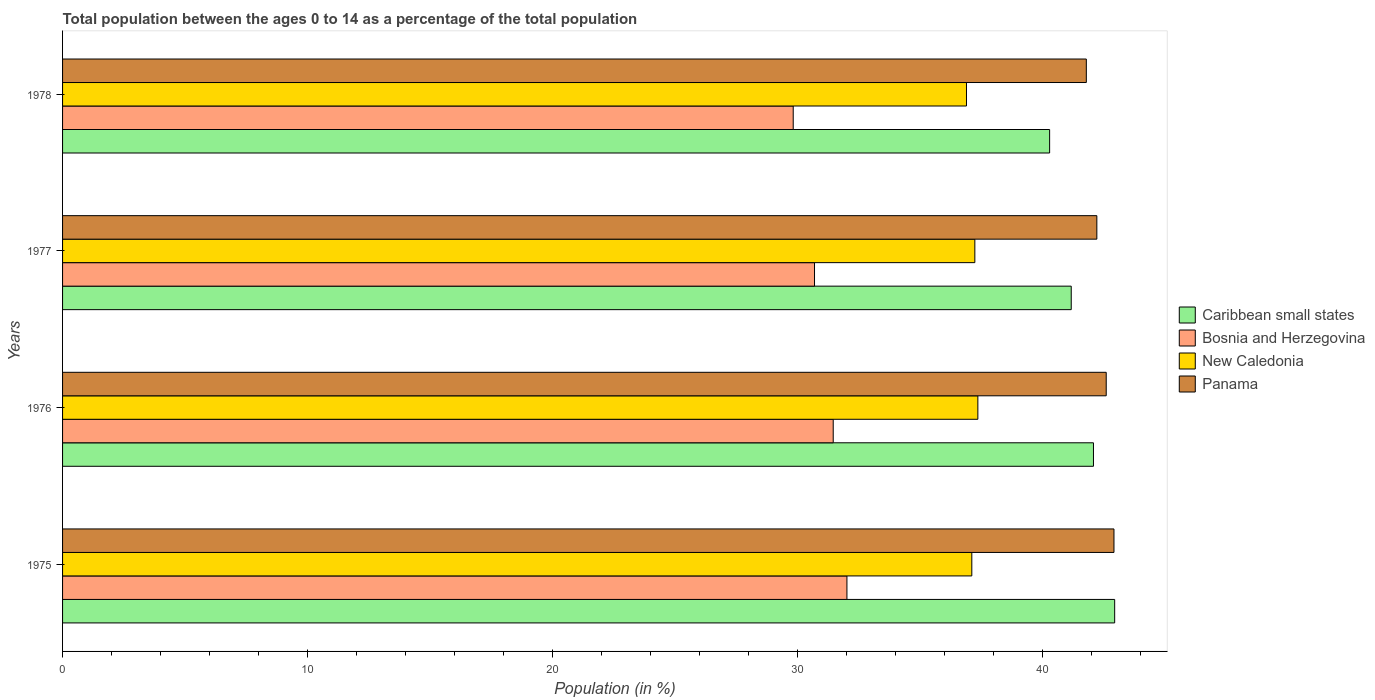How many different coloured bars are there?
Your response must be concise. 4. How many groups of bars are there?
Make the answer very short. 4. Are the number of bars per tick equal to the number of legend labels?
Provide a short and direct response. Yes. Are the number of bars on each tick of the Y-axis equal?
Make the answer very short. Yes. How many bars are there on the 3rd tick from the top?
Provide a short and direct response. 4. How many bars are there on the 4th tick from the bottom?
Your response must be concise. 4. What is the percentage of the population ages 0 to 14 in Panama in 1978?
Make the answer very short. 41.8. Across all years, what is the maximum percentage of the population ages 0 to 14 in Caribbean small states?
Your answer should be compact. 42.95. Across all years, what is the minimum percentage of the population ages 0 to 14 in Panama?
Provide a succinct answer. 41.8. In which year was the percentage of the population ages 0 to 14 in New Caledonia maximum?
Ensure brevity in your answer.  1976. In which year was the percentage of the population ages 0 to 14 in Panama minimum?
Your response must be concise. 1978. What is the total percentage of the population ages 0 to 14 in Caribbean small states in the graph?
Ensure brevity in your answer.  166.52. What is the difference between the percentage of the population ages 0 to 14 in Panama in 1975 and that in 1977?
Offer a terse response. 0.7. What is the difference between the percentage of the population ages 0 to 14 in Bosnia and Herzegovina in 1975 and the percentage of the population ages 0 to 14 in Panama in 1976?
Make the answer very short. -10.59. What is the average percentage of the population ages 0 to 14 in Bosnia and Herzegovina per year?
Keep it short and to the point. 31. In the year 1977, what is the difference between the percentage of the population ages 0 to 14 in New Caledonia and percentage of the population ages 0 to 14 in Bosnia and Herzegovina?
Make the answer very short. 6.55. In how many years, is the percentage of the population ages 0 to 14 in Bosnia and Herzegovina greater than 40 ?
Your answer should be very brief. 0. What is the ratio of the percentage of the population ages 0 to 14 in Panama in 1975 to that in 1977?
Your answer should be compact. 1.02. What is the difference between the highest and the second highest percentage of the population ages 0 to 14 in New Caledonia?
Offer a very short reply. 0.12. What is the difference between the highest and the lowest percentage of the population ages 0 to 14 in Panama?
Ensure brevity in your answer.  1.13. In how many years, is the percentage of the population ages 0 to 14 in Panama greater than the average percentage of the population ages 0 to 14 in Panama taken over all years?
Your answer should be very brief. 2. Is it the case that in every year, the sum of the percentage of the population ages 0 to 14 in Caribbean small states and percentage of the population ages 0 to 14 in Panama is greater than the sum of percentage of the population ages 0 to 14 in Bosnia and Herzegovina and percentage of the population ages 0 to 14 in New Caledonia?
Offer a terse response. Yes. What does the 1st bar from the top in 1978 represents?
Offer a very short reply. Panama. What does the 1st bar from the bottom in 1978 represents?
Offer a very short reply. Caribbean small states. Is it the case that in every year, the sum of the percentage of the population ages 0 to 14 in Caribbean small states and percentage of the population ages 0 to 14 in Bosnia and Herzegovina is greater than the percentage of the population ages 0 to 14 in Panama?
Provide a succinct answer. Yes. What is the difference between two consecutive major ticks on the X-axis?
Provide a succinct answer. 10. Are the values on the major ticks of X-axis written in scientific E-notation?
Offer a terse response. No. Does the graph contain any zero values?
Provide a succinct answer. No. How many legend labels are there?
Make the answer very short. 4. How are the legend labels stacked?
Provide a short and direct response. Vertical. What is the title of the graph?
Provide a short and direct response. Total population between the ages 0 to 14 as a percentage of the total population. Does "Slovenia" appear as one of the legend labels in the graph?
Offer a terse response. No. What is the label or title of the X-axis?
Offer a terse response. Population (in %). What is the label or title of the Y-axis?
Provide a succinct answer. Years. What is the Population (in %) of Caribbean small states in 1975?
Give a very brief answer. 42.95. What is the Population (in %) in Bosnia and Herzegovina in 1975?
Provide a succinct answer. 32.02. What is the Population (in %) in New Caledonia in 1975?
Your answer should be very brief. 37.12. What is the Population (in %) in Panama in 1975?
Give a very brief answer. 42.93. What is the Population (in %) of Caribbean small states in 1976?
Provide a succinct answer. 42.09. What is the Population (in %) of Bosnia and Herzegovina in 1976?
Your answer should be very brief. 31.46. What is the Population (in %) in New Caledonia in 1976?
Ensure brevity in your answer.  37.37. What is the Population (in %) in Panama in 1976?
Your answer should be compact. 42.61. What is the Population (in %) of Caribbean small states in 1977?
Make the answer very short. 41.18. What is the Population (in %) of Bosnia and Herzegovina in 1977?
Ensure brevity in your answer.  30.7. What is the Population (in %) in New Caledonia in 1977?
Your response must be concise. 37.25. What is the Population (in %) in Panama in 1977?
Your answer should be compact. 42.23. What is the Population (in %) of Caribbean small states in 1978?
Provide a short and direct response. 40.3. What is the Population (in %) in Bosnia and Herzegovina in 1978?
Your response must be concise. 29.83. What is the Population (in %) in New Caledonia in 1978?
Provide a succinct answer. 36.9. What is the Population (in %) of Panama in 1978?
Make the answer very short. 41.8. Across all years, what is the maximum Population (in %) of Caribbean small states?
Ensure brevity in your answer.  42.95. Across all years, what is the maximum Population (in %) of Bosnia and Herzegovina?
Give a very brief answer. 32.02. Across all years, what is the maximum Population (in %) of New Caledonia?
Your answer should be compact. 37.37. Across all years, what is the maximum Population (in %) of Panama?
Offer a very short reply. 42.93. Across all years, what is the minimum Population (in %) in Caribbean small states?
Offer a terse response. 40.3. Across all years, what is the minimum Population (in %) in Bosnia and Herzegovina?
Your response must be concise. 29.83. Across all years, what is the minimum Population (in %) in New Caledonia?
Keep it short and to the point. 36.9. Across all years, what is the minimum Population (in %) of Panama?
Provide a succinct answer. 41.8. What is the total Population (in %) in Caribbean small states in the graph?
Your answer should be very brief. 166.52. What is the total Population (in %) in Bosnia and Herzegovina in the graph?
Ensure brevity in your answer.  124.02. What is the total Population (in %) in New Caledonia in the graph?
Keep it short and to the point. 148.64. What is the total Population (in %) in Panama in the graph?
Provide a succinct answer. 169.56. What is the difference between the Population (in %) in Caribbean small states in 1975 and that in 1976?
Ensure brevity in your answer.  0.87. What is the difference between the Population (in %) of Bosnia and Herzegovina in 1975 and that in 1976?
Make the answer very short. 0.56. What is the difference between the Population (in %) of New Caledonia in 1975 and that in 1976?
Keep it short and to the point. -0.25. What is the difference between the Population (in %) of Panama in 1975 and that in 1976?
Your answer should be very brief. 0.32. What is the difference between the Population (in %) of Caribbean small states in 1975 and that in 1977?
Offer a terse response. 1.77. What is the difference between the Population (in %) of Bosnia and Herzegovina in 1975 and that in 1977?
Offer a terse response. 1.32. What is the difference between the Population (in %) in New Caledonia in 1975 and that in 1977?
Offer a very short reply. -0.12. What is the difference between the Population (in %) of Panama in 1975 and that in 1977?
Make the answer very short. 0.7. What is the difference between the Population (in %) of Caribbean small states in 1975 and that in 1978?
Make the answer very short. 2.66. What is the difference between the Population (in %) in Bosnia and Herzegovina in 1975 and that in 1978?
Keep it short and to the point. 2.19. What is the difference between the Population (in %) in New Caledonia in 1975 and that in 1978?
Keep it short and to the point. 0.22. What is the difference between the Population (in %) in Panama in 1975 and that in 1978?
Make the answer very short. 1.13. What is the difference between the Population (in %) in Caribbean small states in 1976 and that in 1977?
Provide a short and direct response. 0.91. What is the difference between the Population (in %) of Bosnia and Herzegovina in 1976 and that in 1977?
Offer a very short reply. 0.76. What is the difference between the Population (in %) of New Caledonia in 1976 and that in 1977?
Make the answer very short. 0.12. What is the difference between the Population (in %) of Panama in 1976 and that in 1977?
Provide a short and direct response. 0.38. What is the difference between the Population (in %) in Caribbean small states in 1976 and that in 1978?
Your response must be concise. 1.79. What is the difference between the Population (in %) in Bosnia and Herzegovina in 1976 and that in 1978?
Ensure brevity in your answer.  1.63. What is the difference between the Population (in %) in New Caledonia in 1976 and that in 1978?
Ensure brevity in your answer.  0.46. What is the difference between the Population (in %) in Panama in 1976 and that in 1978?
Provide a succinct answer. 0.81. What is the difference between the Population (in %) of Caribbean small states in 1977 and that in 1978?
Provide a short and direct response. 0.88. What is the difference between the Population (in %) in Bosnia and Herzegovina in 1977 and that in 1978?
Offer a very short reply. 0.87. What is the difference between the Population (in %) in New Caledonia in 1977 and that in 1978?
Make the answer very short. 0.34. What is the difference between the Population (in %) in Panama in 1977 and that in 1978?
Offer a very short reply. 0.43. What is the difference between the Population (in %) in Caribbean small states in 1975 and the Population (in %) in Bosnia and Herzegovina in 1976?
Your response must be concise. 11.49. What is the difference between the Population (in %) of Caribbean small states in 1975 and the Population (in %) of New Caledonia in 1976?
Offer a very short reply. 5.59. What is the difference between the Population (in %) in Caribbean small states in 1975 and the Population (in %) in Panama in 1976?
Provide a succinct answer. 0.34. What is the difference between the Population (in %) in Bosnia and Herzegovina in 1975 and the Population (in %) in New Caledonia in 1976?
Give a very brief answer. -5.34. What is the difference between the Population (in %) of Bosnia and Herzegovina in 1975 and the Population (in %) of Panama in 1976?
Your response must be concise. -10.59. What is the difference between the Population (in %) of New Caledonia in 1975 and the Population (in %) of Panama in 1976?
Your answer should be compact. -5.49. What is the difference between the Population (in %) of Caribbean small states in 1975 and the Population (in %) of Bosnia and Herzegovina in 1977?
Your answer should be compact. 12.25. What is the difference between the Population (in %) of Caribbean small states in 1975 and the Population (in %) of New Caledonia in 1977?
Offer a very short reply. 5.71. What is the difference between the Population (in %) in Caribbean small states in 1975 and the Population (in %) in Panama in 1977?
Offer a terse response. 0.73. What is the difference between the Population (in %) of Bosnia and Herzegovina in 1975 and the Population (in %) of New Caledonia in 1977?
Offer a very short reply. -5.22. What is the difference between the Population (in %) in Bosnia and Herzegovina in 1975 and the Population (in %) in Panama in 1977?
Give a very brief answer. -10.2. What is the difference between the Population (in %) of New Caledonia in 1975 and the Population (in %) of Panama in 1977?
Provide a succinct answer. -5.1. What is the difference between the Population (in %) of Caribbean small states in 1975 and the Population (in %) of Bosnia and Herzegovina in 1978?
Provide a succinct answer. 13.12. What is the difference between the Population (in %) of Caribbean small states in 1975 and the Population (in %) of New Caledonia in 1978?
Your answer should be compact. 6.05. What is the difference between the Population (in %) of Caribbean small states in 1975 and the Population (in %) of Panama in 1978?
Your answer should be very brief. 1.16. What is the difference between the Population (in %) of Bosnia and Herzegovina in 1975 and the Population (in %) of New Caledonia in 1978?
Provide a short and direct response. -4.88. What is the difference between the Population (in %) of Bosnia and Herzegovina in 1975 and the Population (in %) of Panama in 1978?
Your answer should be very brief. -9.77. What is the difference between the Population (in %) of New Caledonia in 1975 and the Population (in %) of Panama in 1978?
Your answer should be very brief. -4.68. What is the difference between the Population (in %) of Caribbean small states in 1976 and the Population (in %) of Bosnia and Herzegovina in 1977?
Keep it short and to the point. 11.39. What is the difference between the Population (in %) of Caribbean small states in 1976 and the Population (in %) of New Caledonia in 1977?
Provide a short and direct response. 4.84. What is the difference between the Population (in %) in Caribbean small states in 1976 and the Population (in %) in Panama in 1977?
Provide a succinct answer. -0.14. What is the difference between the Population (in %) of Bosnia and Herzegovina in 1976 and the Population (in %) of New Caledonia in 1977?
Keep it short and to the point. -5.78. What is the difference between the Population (in %) of Bosnia and Herzegovina in 1976 and the Population (in %) of Panama in 1977?
Provide a succinct answer. -10.76. What is the difference between the Population (in %) of New Caledonia in 1976 and the Population (in %) of Panama in 1977?
Make the answer very short. -4.86. What is the difference between the Population (in %) of Caribbean small states in 1976 and the Population (in %) of Bosnia and Herzegovina in 1978?
Your answer should be very brief. 12.26. What is the difference between the Population (in %) of Caribbean small states in 1976 and the Population (in %) of New Caledonia in 1978?
Your answer should be compact. 5.18. What is the difference between the Population (in %) of Caribbean small states in 1976 and the Population (in %) of Panama in 1978?
Ensure brevity in your answer.  0.29. What is the difference between the Population (in %) in Bosnia and Herzegovina in 1976 and the Population (in %) in New Caledonia in 1978?
Make the answer very short. -5.44. What is the difference between the Population (in %) in Bosnia and Herzegovina in 1976 and the Population (in %) in Panama in 1978?
Make the answer very short. -10.33. What is the difference between the Population (in %) of New Caledonia in 1976 and the Population (in %) of Panama in 1978?
Give a very brief answer. -4.43. What is the difference between the Population (in %) of Caribbean small states in 1977 and the Population (in %) of Bosnia and Herzegovina in 1978?
Make the answer very short. 11.35. What is the difference between the Population (in %) in Caribbean small states in 1977 and the Population (in %) in New Caledonia in 1978?
Make the answer very short. 4.28. What is the difference between the Population (in %) of Caribbean small states in 1977 and the Population (in %) of Panama in 1978?
Offer a terse response. -0.62. What is the difference between the Population (in %) of Bosnia and Herzegovina in 1977 and the Population (in %) of New Caledonia in 1978?
Offer a terse response. -6.2. What is the difference between the Population (in %) of Bosnia and Herzegovina in 1977 and the Population (in %) of Panama in 1978?
Your answer should be compact. -11.1. What is the difference between the Population (in %) in New Caledonia in 1977 and the Population (in %) in Panama in 1978?
Offer a terse response. -4.55. What is the average Population (in %) of Caribbean small states per year?
Provide a succinct answer. 41.63. What is the average Population (in %) in Bosnia and Herzegovina per year?
Offer a very short reply. 31. What is the average Population (in %) in New Caledonia per year?
Offer a very short reply. 37.16. What is the average Population (in %) of Panama per year?
Offer a very short reply. 42.39. In the year 1975, what is the difference between the Population (in %) of Caribbean small states and Population (in %) of Bosnia and Herzegovina?
Keep it short and to the point. 10.93. In the year 1975, what is the difference between the Population (in %) of Caribbean small states and Population (in %) of New Caledonia?
Your answer should be compact. 5.83. In the year 1975, what is the difference between the Population (in %) of Caribbean small states and Population (in %) of Panama?
Give a very brief answer. 0.03. In the year 1975, what is the difference between the Population (in %) of Bosnia and Herzegovina and Population (in %) of New Caledonia?
Keep it short and to the point. -5.1. In the year 1975, what is the difference between the Population (in %) of Bosnia and Herzegovina and Population (in %) of Panama?
Your answer should be compact. -10.9. In the year 1975, what is the difference between the Population (in %) of New Caledonia and Population (in %) of Panama?
Ensure brevity in your answer.  -5.8. In the year 1976, what is the difference between the Population (in %) in Caribbean small states and Population (in %) in Bosnia and Herzegovina?
Give a very brief answer. 10.62. In the year 1976, what is the difference between the Population (in %) in Caribbean small states and Population (in %) in New Caledonia?
Provide a short and direct response. 4.72. In the year 1976, what is the difference between the Population (in %) in Caribbean small states and Population (in %) in Panama?
Provide a short and direct response. -0.52. In the year 1976, what is the difference between the Population (in %) in Bosnia and Herzegovina and Population (in %) in New Caledonia?
Provide a succinct answer. -5.91. In the year 1976, what is the difference between the Population (in %) in Bosnia and Herzegovina and Population (in %) in Panama?
Your response must be concise. -11.15. In the year 1976, what is the difference between the Population (in %) of New Caledonia and Population (in %) of Panama?
Your answer should be very brief. -5.24. In the year 1977, what is the difference between the Population (in %) of Caribbean small states and Population (in %) of Bosnia and Herzegovina?
Give a very brief answer. 10.48. In the year 1977, what is the difference between the Population (in %) in Caribbean small states and Population (in %) in New Caledonia?
Offer a very short reply. 3.94. In the year 1977, what is the difference between the Population (in %) of Caribbean small states and Population (in %) of Panama?
Provide a succinct answer. -1.05. In the year 1977, what is the difference between the Population (in %) in Bosnia and Herzegovina and Population (in %) in New Caledonia?
Your answer should be compact. -6.55. In the year 1977, what is the difference between the Population (in %) in Bosnia and Herzegovina and Population (in %) in Panama?
Your answer should be very brief. -11.53. In the year 1977, what is the difference between the Population (in %) in New Caledonia and Population (in %) in Panama?
Your answer should be compact. -4.98. In the year 1978, what is the difference between the Population (in %) in Caribbean small states and Population (in %) in Bosnia and Herzegovina?
Your answer should be compact. 10.47. In the year 1978, what is the difference between the Population (in %) in Caribbean small states and Population (in %) in New Caledonia?
Provide a succinct answer. 3.39. In the year 1978, what is the difference between the Population (in %) of Caribbean small states and Population (in %) of Panama?
Offer a very short reply. -1.5. In the year 1978, what is the difference between the Population (in %) in Bosnia and Herzegovina and Population (in %) in New Caledonia?
Offer a very short reply. -7.07. In the year 1978, what is the difference between the Population (in %) of Bosnia and Herzegovina and Population (in %) of Panama?
Ensure brevity in your answer.  -11.97. In the year 1978, what is the difference between the Population (in %) of New Caledonia and Population (in %) of Panama?
Your response must be concise. -4.89. What is the ratio of the Population (in %) in Caribbean small states in 1975 to that in 1976?
Offer a terse response. 1.02. What is the ratio of the Population (in %) in Bosnia and Herzegovina in 1975 to that in 1976?
Ensure brevity in your answer.  1.02. What is the ratio of the Population (in %) of New Caledonia in 1975 to that in 1976?
Your answer should be very brief. 0.99. What is the ratio of the Population (in %) in Panama in 1975 to that in 1976?
Your answer should be very brief. 1.01. What is the ratio of the Population (in %) in Caribbean small states in 1975 to that in 1977?
Make the answer very short. 1.04. What is the ratio of the Population (in %) of Bosnia and Herzegovina in 1975 to that in 1977?
Ensure brevity in your answer.  1.04. What is the ratio of the Population (in %) of New Caledonia in 1975 to that in 1977?
Your answer should be very brief. 1. What is the ratio of the Population (in %) in Panama in 1975 to that in 1977?
Your answer should be very brief. 1.02. What is the ratio of the Population (in %) of Caribbean small states in 1975 to that in 1978?
Offer a very short reply. 1.07. What is the ratio of the Population (in %) of Bosnia and Herzegovina in 1975 to that in 1978?
Provide a short and direct response. 1.07. What is the ratio of the Population (in %) in New Caledonia in 1975 to that in 1978?
Give a very brief answer. 1.01. What is the ratio of the Population (in %) in Bosnia and Herzegovina in 1976 to that in 1977?
Provide a succinct answer. 1.02. What is the ratio of the Population (in %) in New Caledonia in 1976 to that in 1977?
Your answer should be compact. 1. What is the ratio of the Population (in %) in Panama in 1976 to that in 1977?
Your response must be concise. 1.01. What is the ratio of the Population (in %) in Caribbean small states in 1976 to that in 1978?
Your answer should be very brief. 1.04. What is the ratio of the Population (in %) of Bosnia and Herzegovina in 1976 to that in 1978?
Offer a very short reply. 1.05. What is the ratio of the Population (in %) in New Caledonia in 1976 to that in 1978?
Offer a very short reply. 1.01. What is the ratio of the Population (in %) of Panama in 1976 to that in 1978?
Make the answer very short. 1.02. What is the ratio of the Population (in %) of Caribbean small states in 1977 to that in 1978?
Keep it short and to the point. 1.02. What is the ratio of the Population (in %) in Bosnia and Herzegovina in 1977 to that in 1978?
Provide a short and direct response. 1.03. What is the ratio of the Population (in %) in New Caledonia in 1977 to that in 1978?
Your answer should be very brief. 1.01. What is the ratio of the Population (in %) of Panama in 1977 to that in 1978?
Your response must be concise. 1.01. What is the difference between the highest and the second highest Population (in %) of Caribbean small states?
Your answer should be very brief. 0.87. What is the difference between the highest and the second highest Population (in %) of Bosnia and Herzegovina?
Give a very brief answer. 0.56. What is the difference between the highest and the second highest Population (in %) in New Caledonia?
Offer a very short reply. 0.12. What is the difference between the highest and the second highest Population (in %) in Panama?
Offer a very short reply. 0.32. What is the difference between the highest and the lowest Population (in %) of Caribbean small states?
Offer a terse response. 2.66. What is the difference between the highest and the lowest Population (in %) of Bosnia and Herzegovina?
Your answer should be very brief. 2.19. What is the difference between the highest and the lowest Population (in %) of New Caledonia?
Give a very brief answer. 0.46. What is the difference between the highest and the lowest Population (in %) of Panama?
Your answer should be very brief. 1.13. 